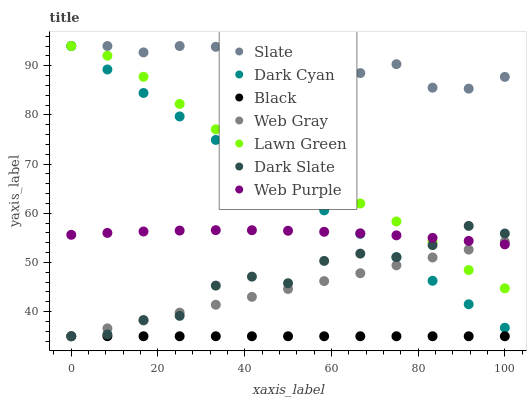Does Black have the minimum area under the curve?
Answer yes or no. Yes. Does Slate have the maximum area under the curve?
Answer yes or no. Yes. Does Web Gray have the minimum area under the curve?
Answer yes or no. No. Does Web Gray have the maximum area under the curve?
Answer yes or no. No. Is Web Gray the smoothest?
Answer yes or no. Yes. Is Dark Slate the roughest?
Answer yes or no. Yes. Is Slate the smoothest?
Answer yes or no. No. Is Slate the roughest?
Answer yes or no. No. Does Web Gray have the lowest value?
Answer yes or no. Yes. Does Slate have the lowest value?
Answer yes or no. No. Does Dark Cyan have the highest value?
Answer yes or no. Yes. Does Web Gray have the highest value?
Answer yes or no. No. Is Web Purple less than Slate?
Answer yes or no. Yes. Is Slate greater than Web Gray?
Answer yes or no. Yes. Does Web Gray intersect Dark Cyan?
Answer yes or no. Yes. Is Web Gray less than Dark Cyan?
Answer yes or no. No. Is Web Gray greater than Dark Cyan?
Answer yes or no. No. Does Web Purple intersect Slate?
Answer yes or no. No. 